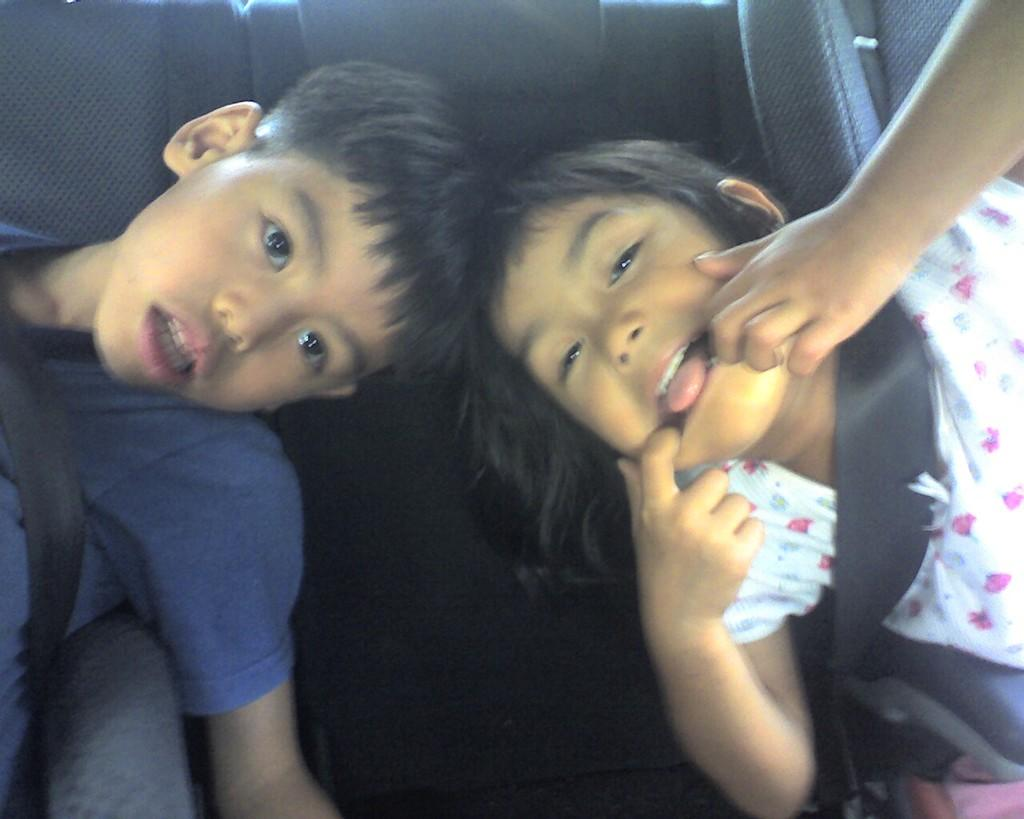Who is present in the image? There is a boy and a girl in the image. What are the boy and girl wearing? The boy is wearing a blue t-shirt, and the girl is wearing a white and pink dress. What are the boy and girl doing in the image? Both the boy and girl are sitting on chairs. What color are the chairs? The chairs are black in color. Where are the chairs located? The chairs are inside a vehicle. What type of stove can be seen in the image? There is no stove present in the image. What role does the governor play in the image? There is no governor present in the image, and therefore no role for them to play. 